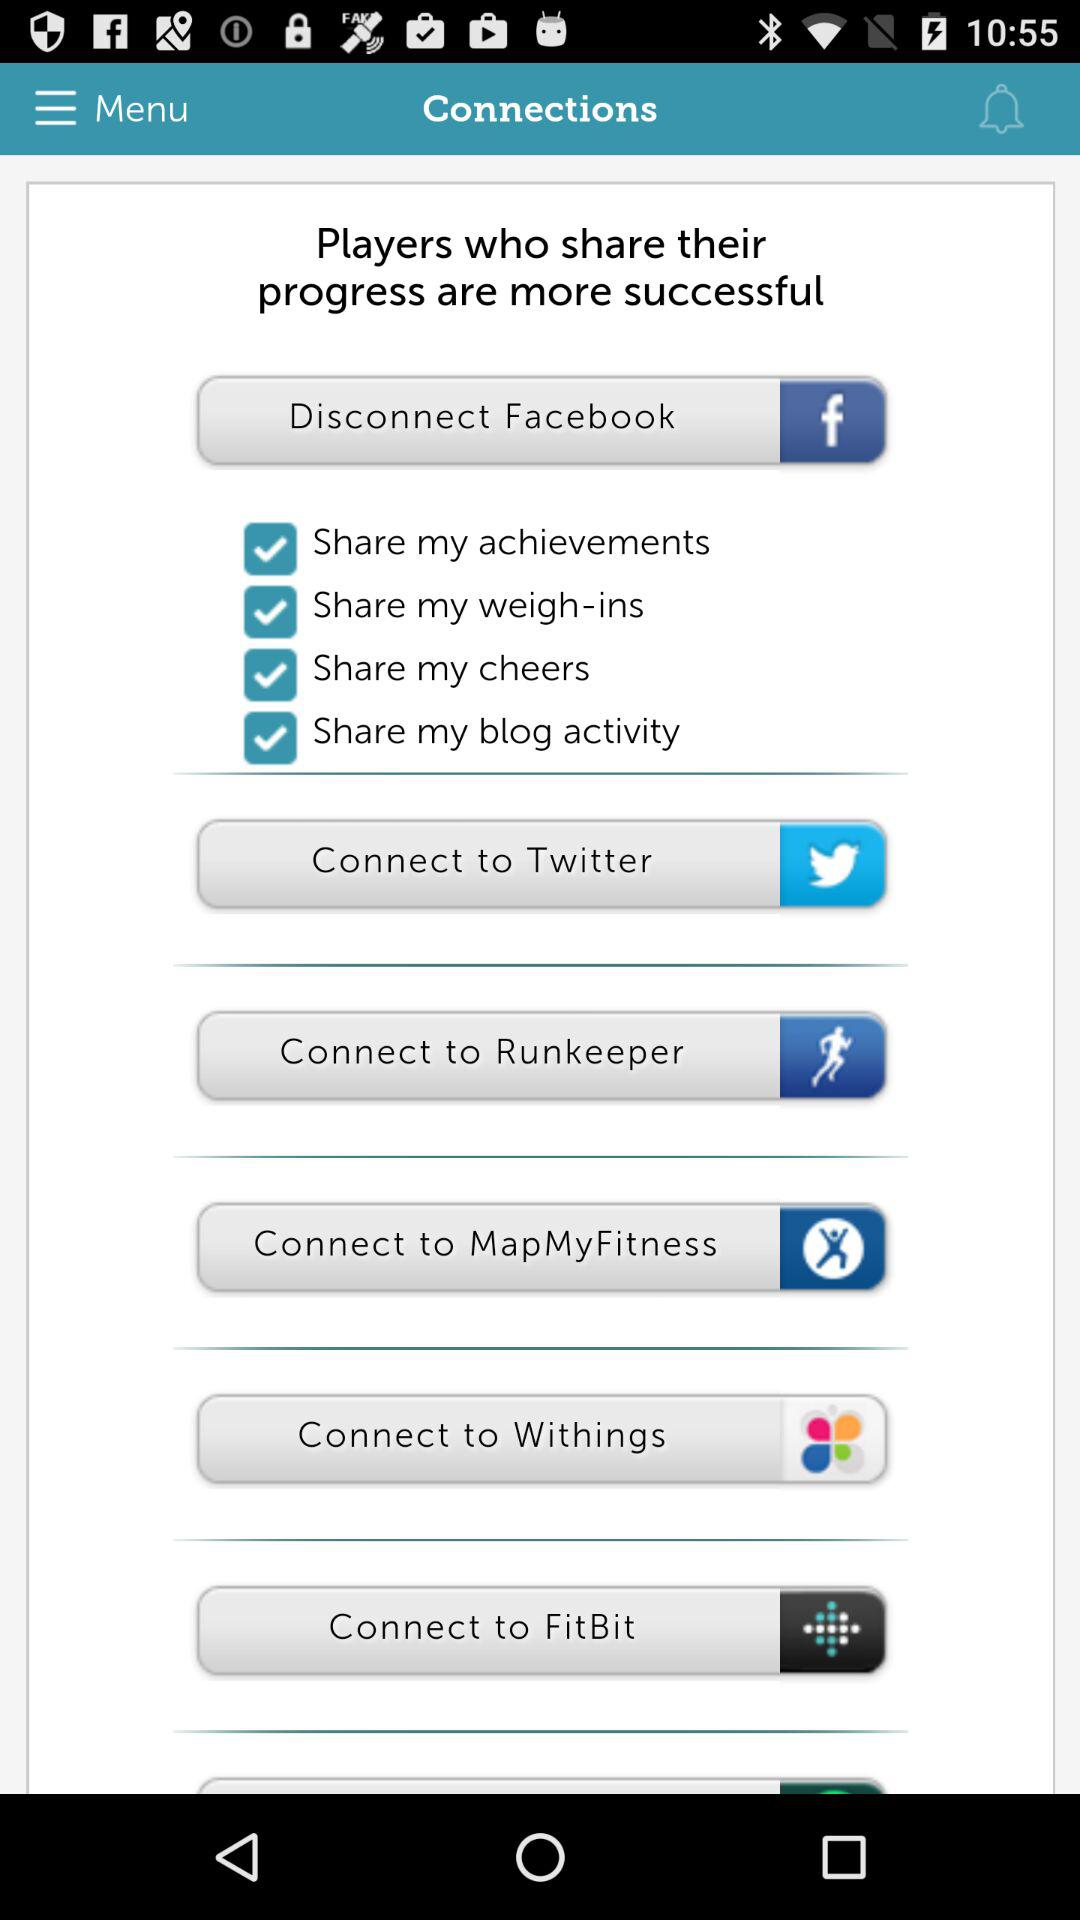What is the checked checkbox? The checked checkboxes are "Share my achievements", "Share my weigh-ins", "Share my cheers" and "Share my blog activity". 